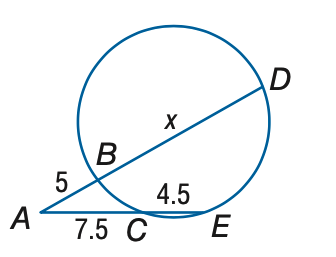Answer the mathemtical geometry problem and directly provide the correct option letter.
Question: Find x.
Choices: A: 12 B: 13 C: 14 D: 15 B 